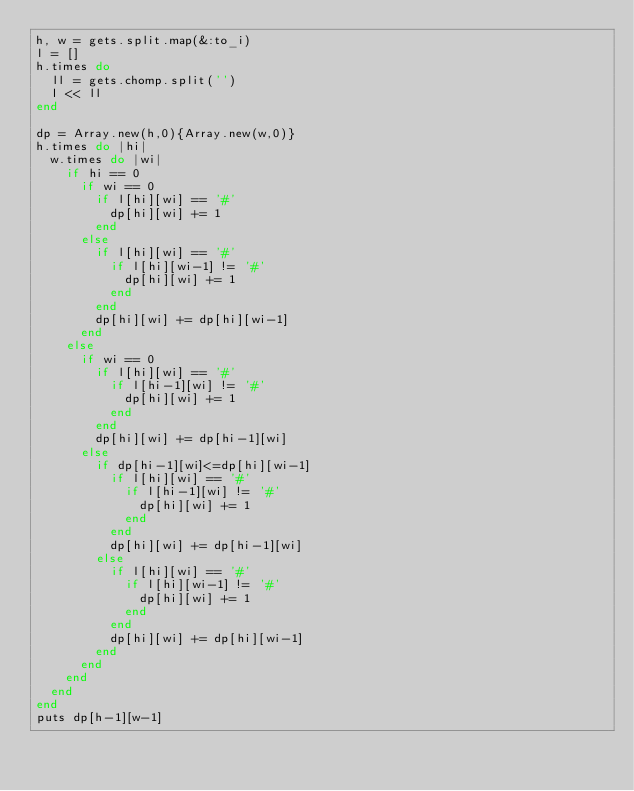<code> <loc_0><loc_0><loc_500><loc_500><_Ruby_>h, w = gets.split.map(&:to_i)
l = []
h.times do
  ll = gets.chomp.split('')
  l << ll
end

dp = Array.new(h,0){Array.new(w,0)}
h.times do |hi|
  w.times do |wi|
    if hi == 0
      if wi == 0
        if l[hi][wi] == '#'
          dp[hi][wi] += 1
        end
      else
        if l[hi][wi] == '#'
          if l[hi][wi-1] != '#'
            dp[hi][wi] += 1
          end
        end
        dp[hi][wi] += dp[hi][wi-1]
      end
    else
      if wi == 0
        if l[hi][wi] == '#'
          if l[hi-1][wi] != '#'
            dp[hi][wi] += 1
          end
        end
        dp[hi][wi] += dp[hi-1][wi]
      else
        if dp[hi-1][wi]<=dp[hi][wi-1]
          if l[hi][wi] == '#'
            if l[hi-1][wi] != '#'
              dp[hi][wi] += 1
            end
          end
          dp[hi][wi] += dp[hi-1][wi]
        else
          if l[hi][wi] == '#'
            if l[hi][wi-1] != '#'
              dp[hi][wi] += 1
            end
          end
          dp[hi][wi] += dp[hi][wi-1]
        end
      end
    end
  end
end
puts dp[h-1][w-1]
</code> 